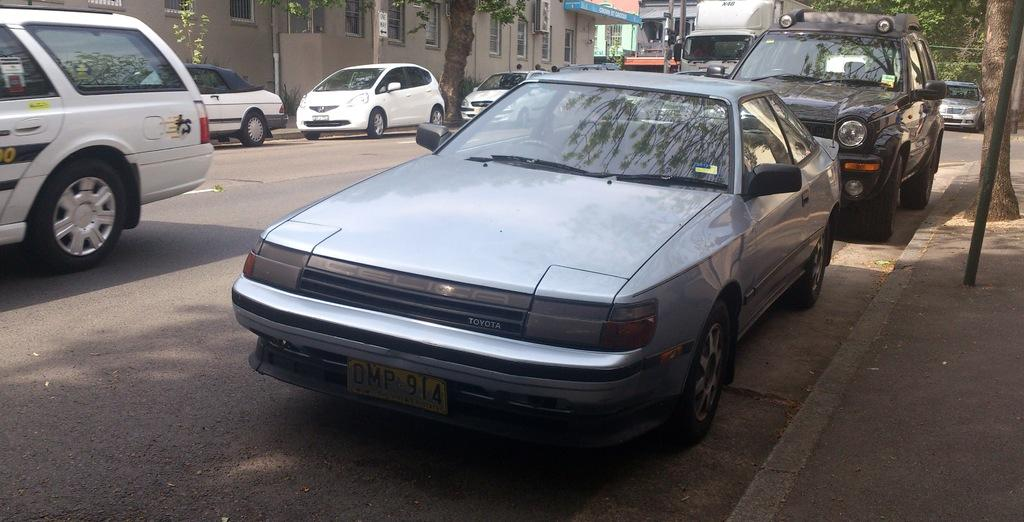What is the main feature of the image? There is a road in the image. What is happening on the road? There are vehicles on the road. What can be seen in the background of the image? There are trees and buildings visible in the image. What else is present in the image? There are poles in the image. Is there any text or writing visible in the image? Yes, there is text or writing visible in the image. What type of protest is taking place on the road in the image? There is no protest visible in the image; it only shows a road with vehicles, trees, buildings, poles, and text or writing. Can you see a bottle on the road in the image? There is no bottle visible on the road in the image. 